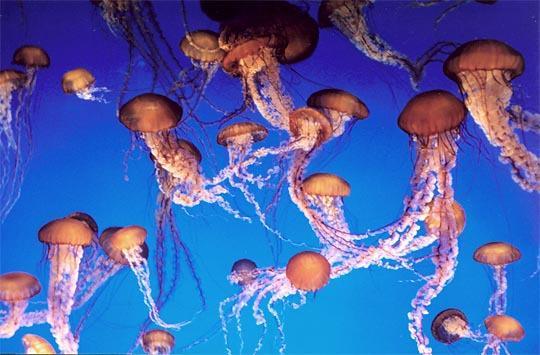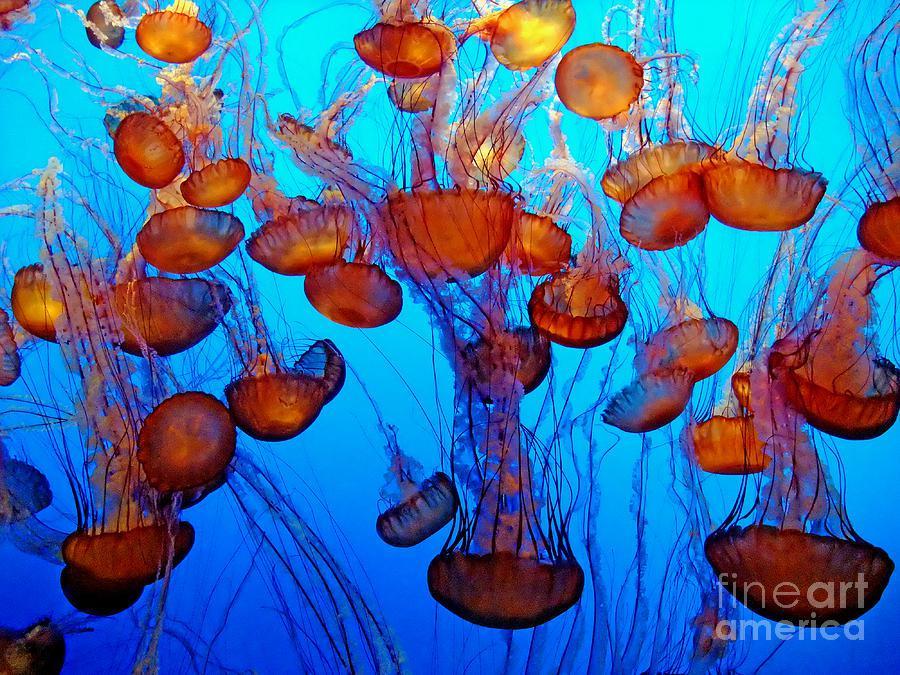The first image is the image on the left, the second image is the image on the right. For the images shown, is this caption "Each image includes at least six orange jellyfish with long tendrils." true? Answer yes or no. Yes. The first image is the image on the left, the second image is the image on the right. Assess this claim about the two images: "There are deep red jellyfish and another with shadows of people". Correct or not? Answer yes or no. No. 